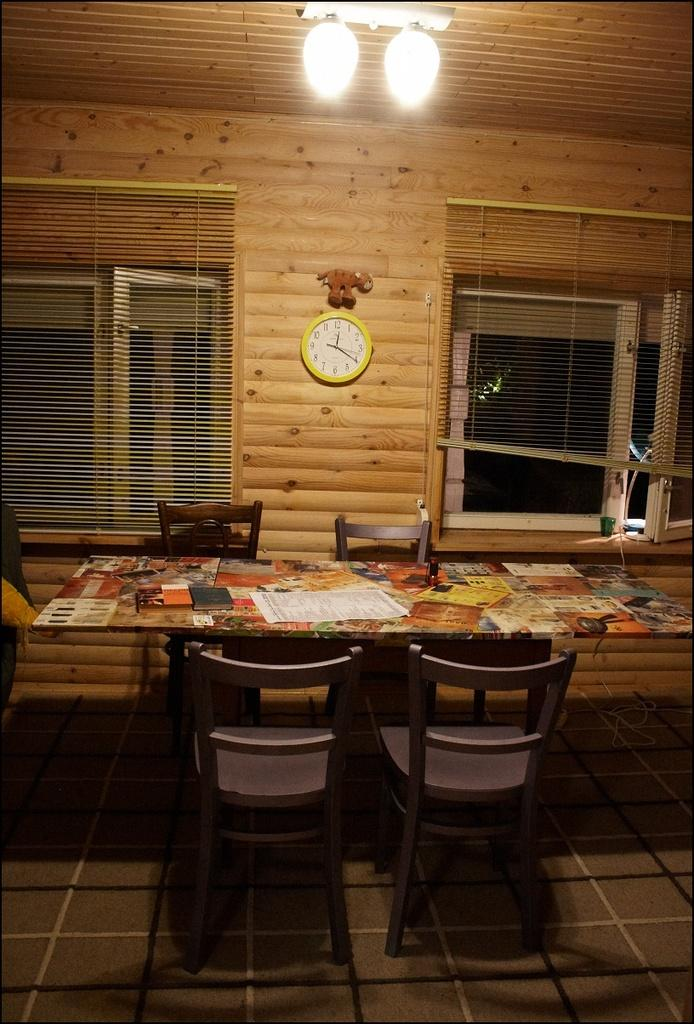What type of space is depicted in the image? The image is of a room. What can be seen on the ceiling of the room? There are lights on top in the room. What time-telling device is present on the wall? There is a clock on the wall. What type of furniture is in the room? There are chairs in the room. What other piece of furniture is in the room? There is a table in the room. What items are on the table? There are books and papers on the table. Is there a source of natural light in the room? Yes, there is a window in the room. What grade does the basketball receive in the image? There is no basketball present in the image, so it cannot receive a grade. 